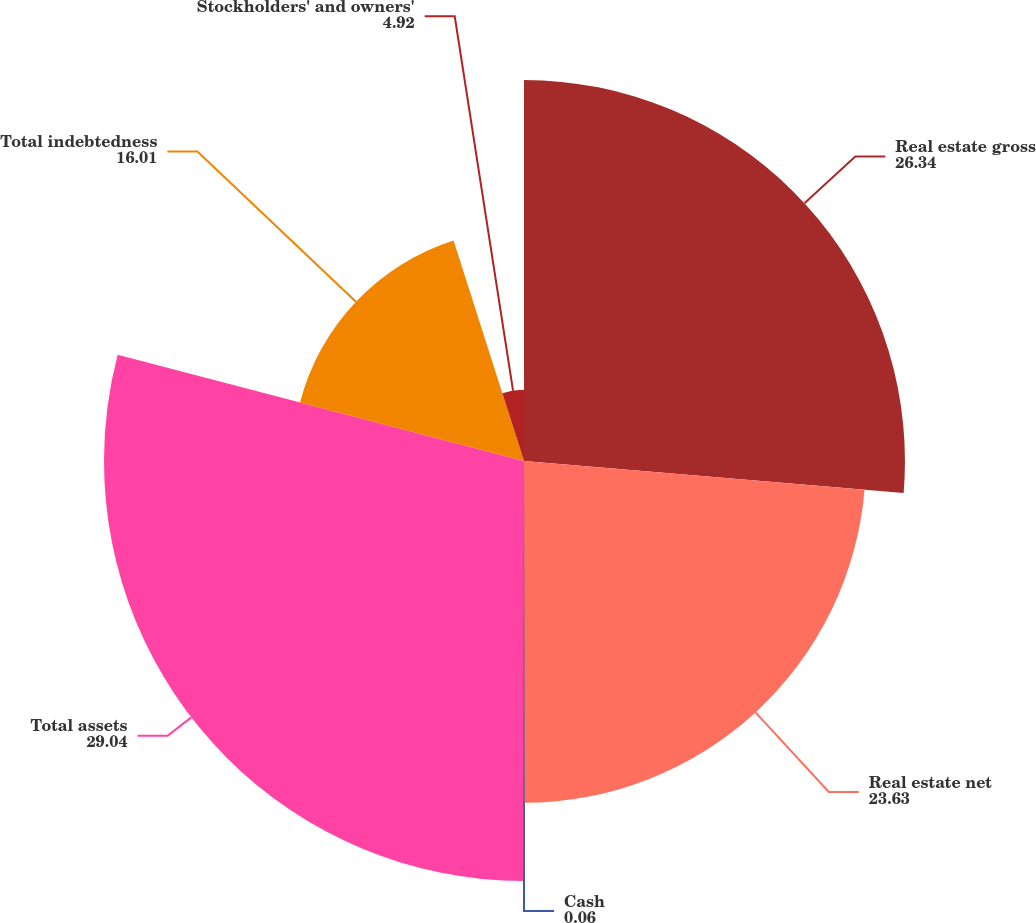Convert chart. <chart><loc_0><loc_0><loc_500><loc_500><pie_chart><fcel>Real estate gross<fcel>Real estate net<fcel>Cash<fcel>Total assets<fcel>Total indebtedness<fcel>Stockholders' and owners'<nl><fcel>26.34%<fcel>23.63%<fcel>0.06%<fcel>29.04%<fcel>16.01%<fcel>4.92%<nl></chart> 